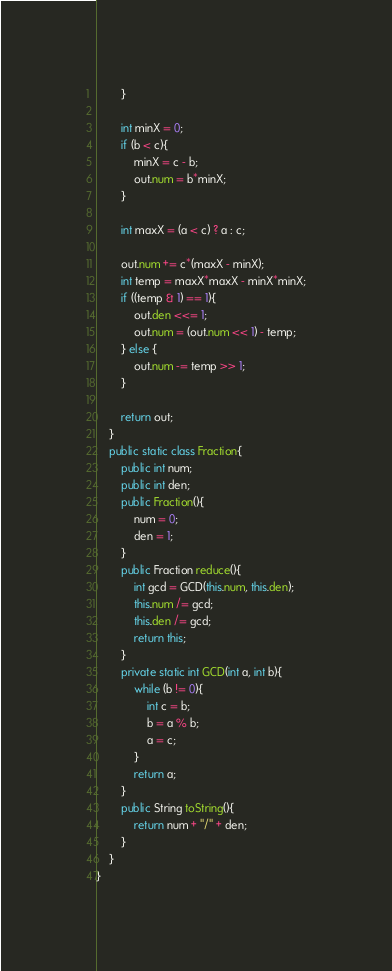<code> <loc_0><loc_0><loc_500><loc_500><_Java_>        }
        
        int minX = 0;
        if (b < c){
            minX = c - b;
            out.num = b*minX;
        }
        
        int maxX = (a < c) ? a : c;
        
        out.num += c*(maxX - minX);
        int temp = maxX*maxX - minX*minX;
        if ((temp & 1) == 1){
            out.den <<= 1;
            out.num = (out.num << 1) - temp;
        } else {
            out.num -= temp >> 1;
        }
        
        return out;
    }
    public static class Fraction{
        public int num;
        public int den;
        public Fraction(){
            num = 0;
            den = 1;
        }
        public Fraction reduce(){
            int gcd = GCD(this.num, this.den);
            this.num /= gcd;
            this.den /= gcd;
            return this;
        }
        private static int GCD(int a, int b){
            while (b != 0){
                int c = b;
                b = a % b;
                a = c;
            }
            return a;
        }
        public String toString(){
            return num + "/" + den;
        }
    }
}
</code> 